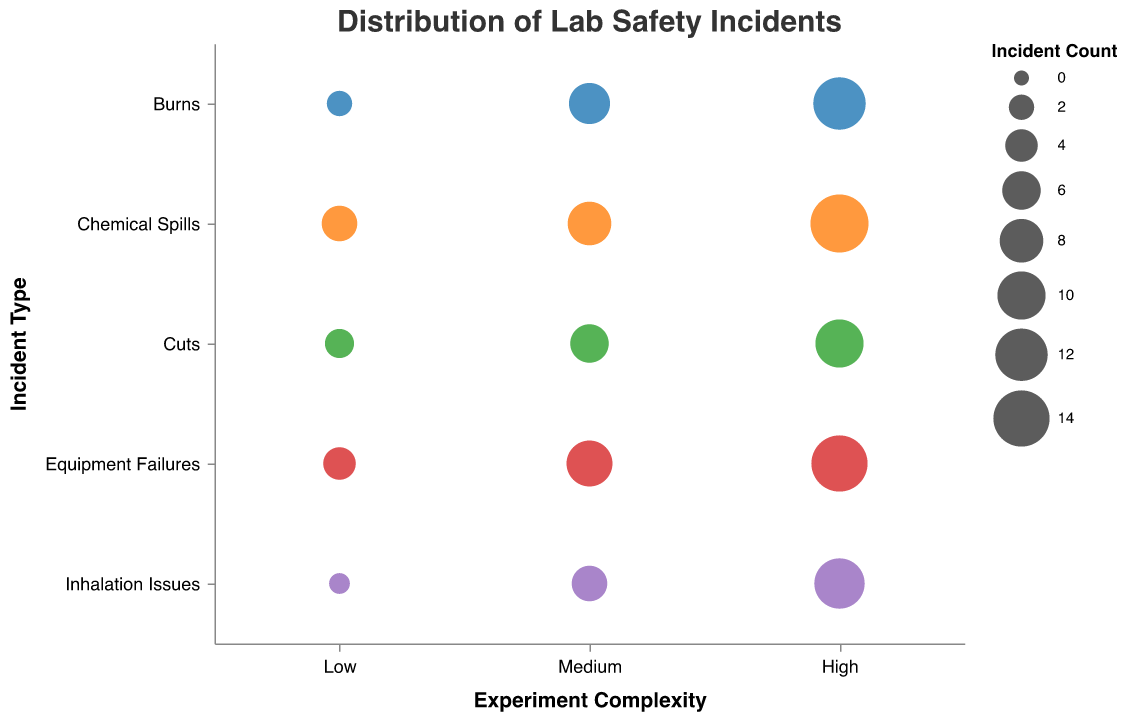What's the title of the figure? The title is located at the top of the chart. It is displayed in a larger font compared to other text.
Answer: Distribution of Lab Safety Incidents Which incident type has the highest number of incidents in a high complexity experiment? To find this, look at the bubbles in the "High" column for each "Incident Type" row. The largest bubble in this column represents the highest number of incidents.
Answer: Chemical Spills How many different experiment complexity levels are displayed in the chart? Count the unique labels on the x-axis. The labels (Low, Medium, High) indicate the levels of experiment complexity.
Answer: 3 Which incident type has the smallest incident count for low complexity experiments? Look at the "Low" column and identify the smallest bubble. The tooltip or legend can indicate the precise count.
Answer: Inhalation Issues Compare the incident counts of Burns and Cuts in medium complexity experiments. Which is higher? Locate the "Medium" column for both "Burns" and "Cuts" rows. Compare the sizes of the bubbles.
Answer: Burns What is the total incident count for Chemical Spills across all complexity levels? Sum the incident counts for Chemical Spills at Low, Medium, and High complexity levels (5 + 8 + 15).
Answer: 28 Which incident type shows the most significant increase in incidents from low to high experiment complexity? To determine this, subtract the incident counts from Low to High for each incident type and identify the one with the largest difference. For Chemical Spills (15 - 5 = 10), Burns (12 - 2 = 10), Cuts (10 - 3 = 7), Equipment Failures (14 - 4 = 10), Inhalation Issues (11 - 1 = 10).
Answer: Chemical Spills, Burns, Equipment Failures, and Inhalation Issues Between Equipment Failures and Inhalation Issues, which has a more considerable bubble size difference between medium and high complexity? Calculate the difference in incident count for "Medium" and "High" for both. Equipment Failures: 14 - 9 = 5, Inhalation Issues: 11 - 5 = 6. Compare the differences.
Answer: Inhalation Issues What patterns can be identified in the distribution of incident counts across all experiment complexities for any specific incident type? Describe the changes in bubble sizes from Low to High for any incident type. This typically involves an increasing trend as experiment complexity increases.
Answer: Incidents generally increase as experiment complexity goes up How many incident types experience more than 10 incidents in high complexity experiments? Identify and count the bubbles in the "High" column with an incident count greater than 10.
Answer: 4 